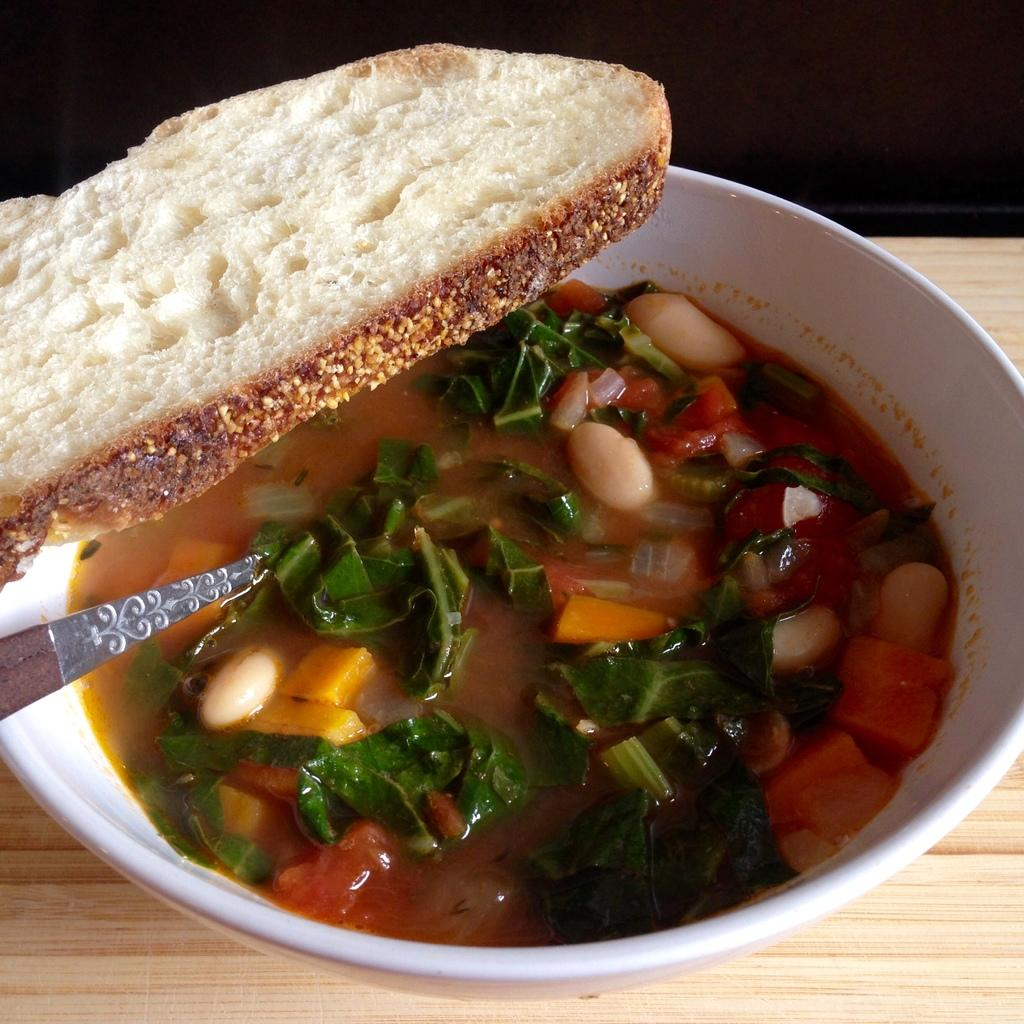What is in the bowl that is visible in the image? There is a bowl with curry in the image. What utensil is present in the bowl? A spoon is present in the bowl. Where is the bowl placed? The bowl is placed on a wooden plank. What accompanies the bowl of curry? There is a slice of bread on top of the bowl. What type of punishment is being administered with the curry in the image? There is no indication of punishment in the image; it simply shows a bowl of curry with a spoon and a slice of bread. 